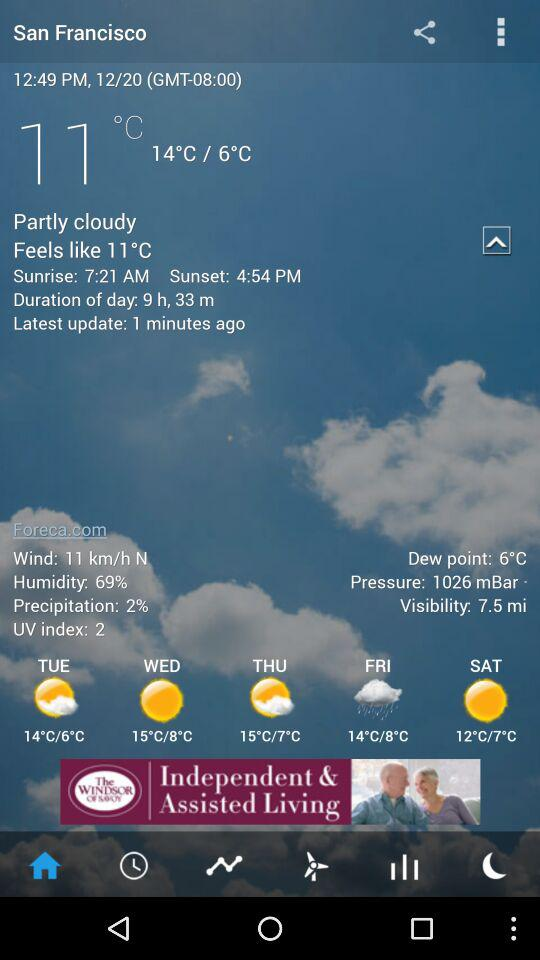How many hours of daylight are there today?
Answer the question using a single word or phrase. 9 h, 33 m 